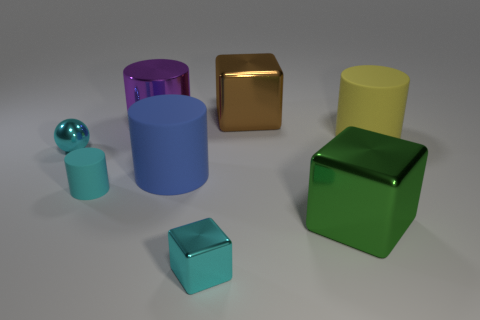Subtract all red cylinders. Subtract all purple balls. How many cylinders are left? 4 Add 1 big rubber objects. How many objects exist? 9 Subtract all balls. How many objects are left? 7 Subtract all big yellow things. Subtract all shiny things. How many objects are left? 2 Add 4 metal cylinders. How many metal cylinders are left? 5 Add 5 tiny purple shiny cylinders. How many tiny purple shiny cylinders exist? 5 Subtract 1 purple cylinders. How many objects are left? 7 